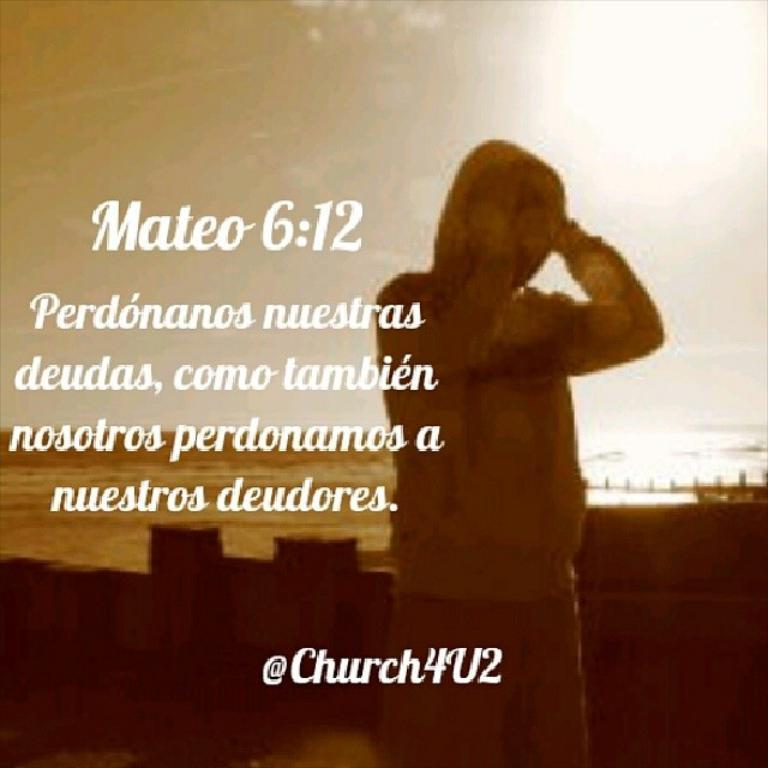What is the main subject of the image? There is a person in the image. What can be seen on the left side of the image? There is text or writing on the left side of the image. Can you tell if the image has been altered or edited in any way? The image appears to be edited. Is the person in the image sleeping on a seat? There is no information about the person sleeping or a seat in the image, so we cannot answer that question. 